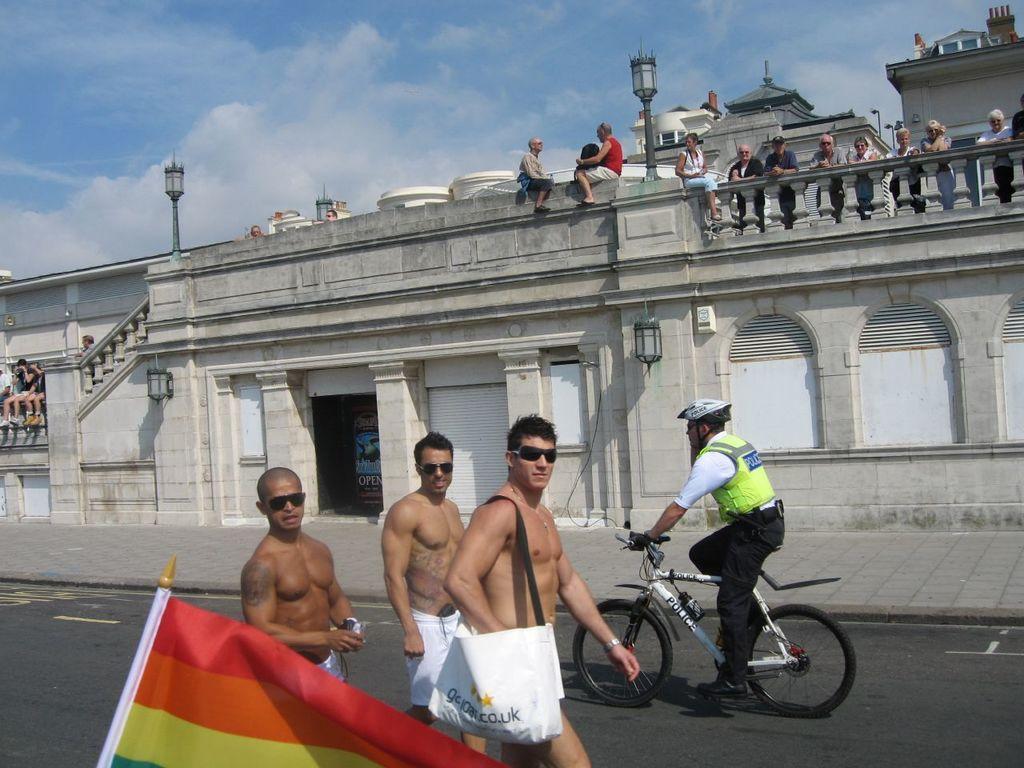In one or two sentences, can you explain what this image depicts? In this picture there are three man walking on the road, wearing shorts and a bag on his shoulders. One of the guys, riding a bicycle. In the background there are some people Standing and watching. We can observe a wall and sky with some clouds here. 